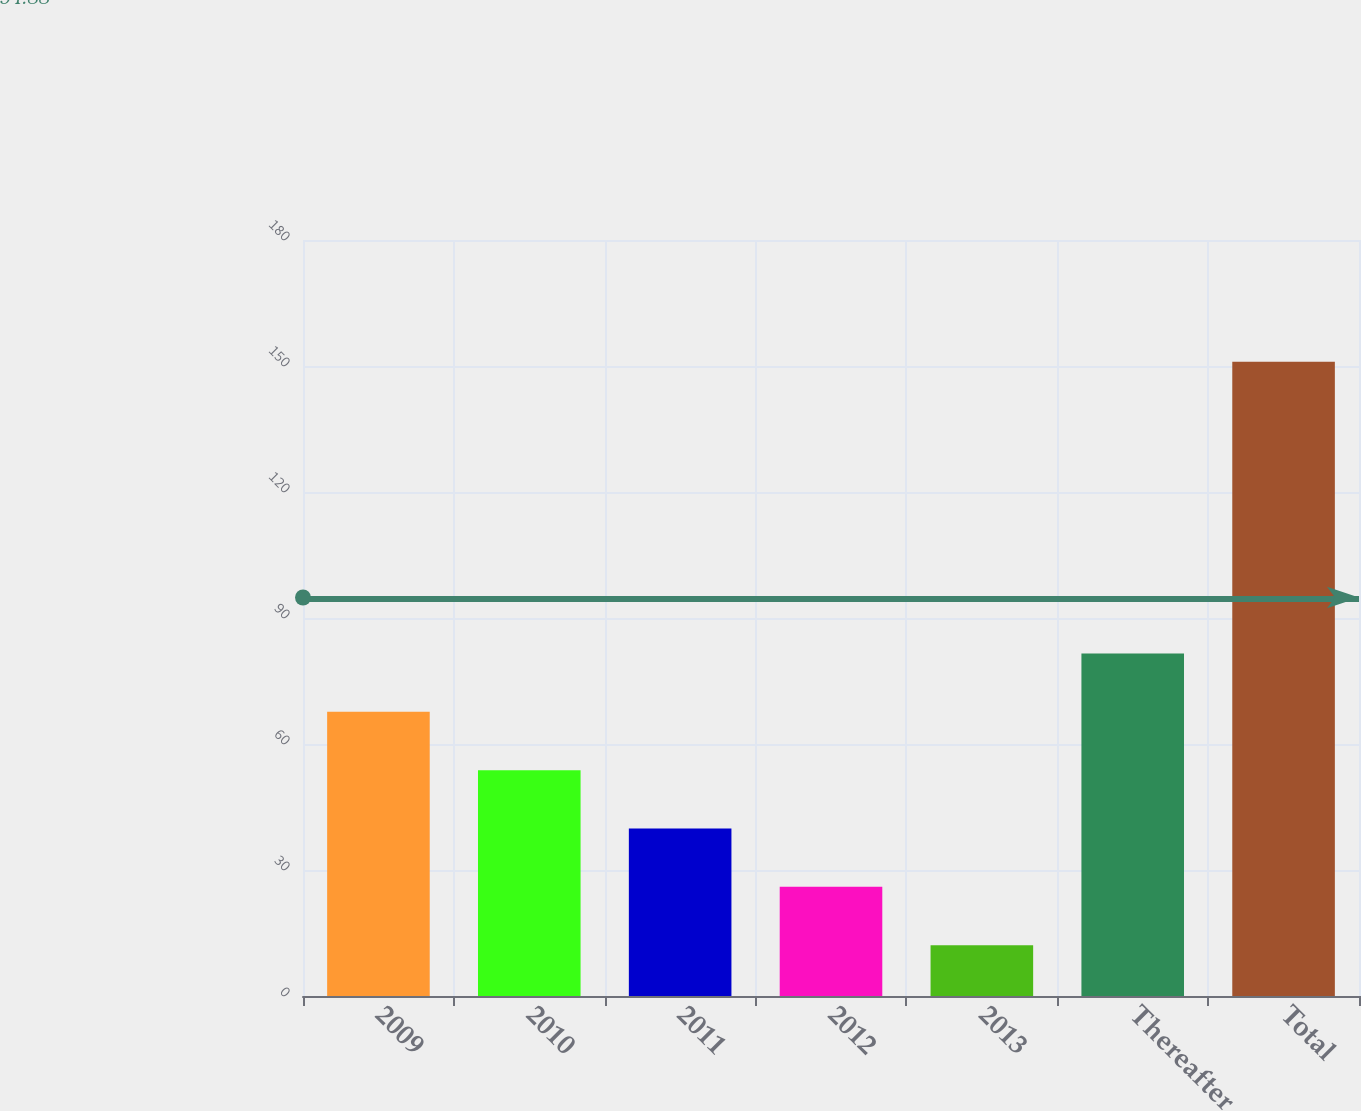<chart> <loc_0><loc_0><loc_500><loc_500><bar_chart><fcel>2009<fcel>2010<fcel>2011<fcel>2012<fcel>2013<fcel>Thereafter<fcel>Total<nl><fcel>67.66<fcel>53.77<fcel>39.88<fcel>25.99<fcel>12.1<fcel>81.55<fcel>151<nl></chart> 